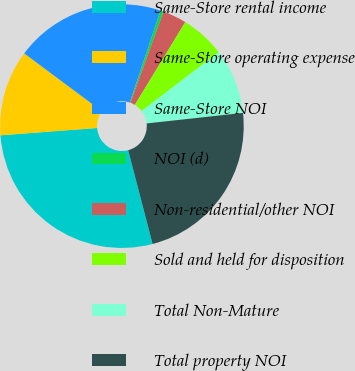Convert chart. <chart><loc_0><loc_0><loc_500><loc_500><pie_chart><fcel>Same-Store rental income<fcel>Same-Store operating expense<fcel>Same-Store NOI<fcel>NOI (d)<fcel>Non-residential/other NOI<fcel>Sold and held for disposition<fcel>Total Non-Mature<fcel>Total property NOI<nl><fcel>27.85%<fcel>11.39%<fcel>19.94%<fcel>0.42%<fcel>3.16%<fcel>5.91%<fcel>8.65%<fcel>22.68%<nl></chart> 